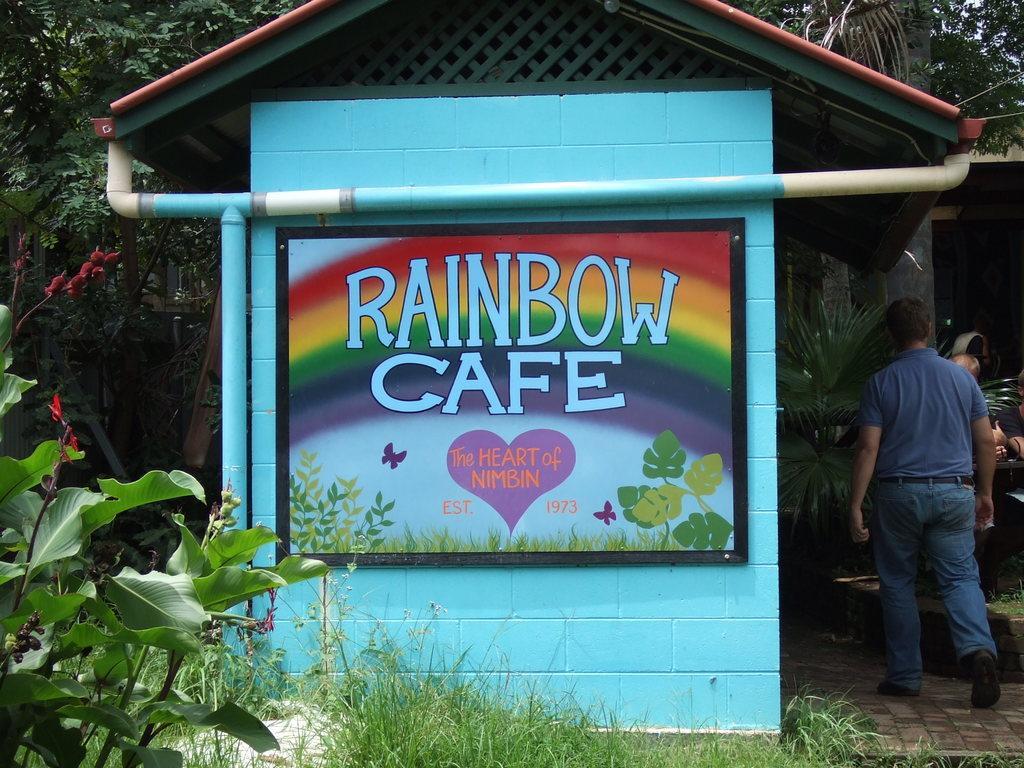Please provide a concise description of this image. In this picture I can observe a cafe which is in blue color. On the right side there is a person walking on the floor. I can observe some grass and plants in this picture. In the background there are some trees. 